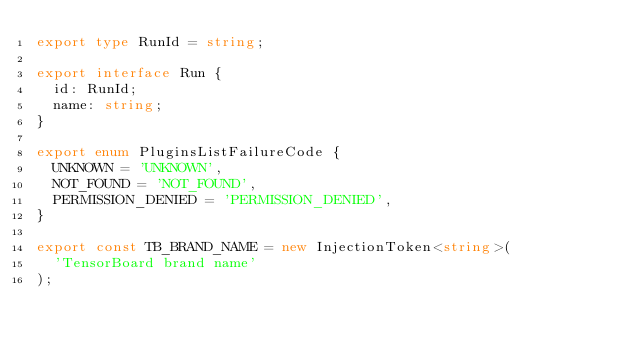<code> <loc_0><loc_0><loc_500><loc_500><_TypeScript_>export type RunId = string;

export interface Run {
  id: RunId;
  name: string;
}

export enum PluginsListFailureCode {
  UNKNOWN = 'UNKNOWN',
  NOT_FOUND = 'NOT_FOUND',
  PERMISSION_DENIED = 'PERMISSION_DENIED',
}

export const TB_BRAND_NAME = new InjectionToken<string>(
  'TensorBoard brand name'
);
</code> 